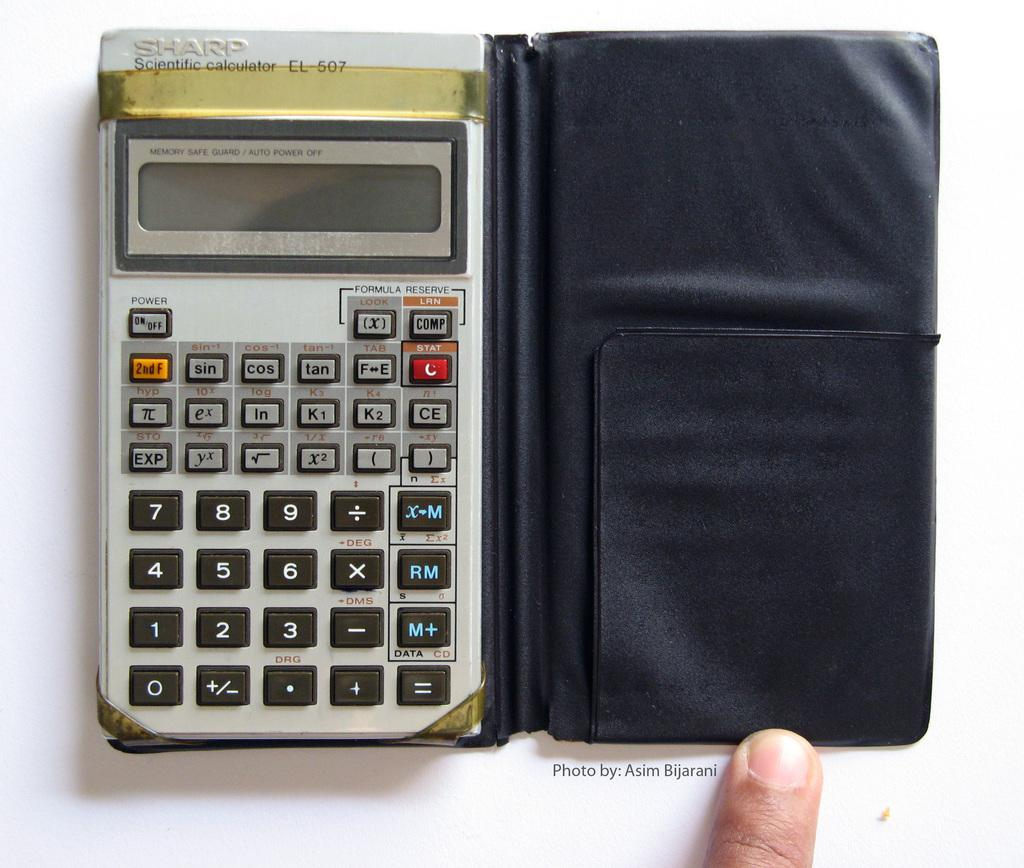Provide a one-sentence caption for the provided image. Sharp scientific calculators are useful for a variety of advanced mathematical functions. 